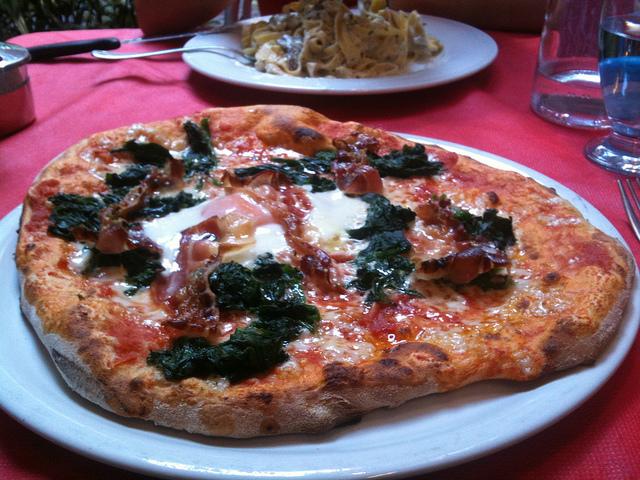Is this pizza house-made?
Be succinct. Yes. How much cheese is on the pizza?
Keep it brief. Little. What is the table made of?
Concise answer only. Wood. What toppings are on this pizza?
Give a very brief answer. Bacon and spinach. What type of vegetable is next to the pizza?
Be succinct. Spinach. Is the table cloth cotton or man made fibers?
Answer briefly. Cotton. Is there a fork on the table?
Quick response, please. Yes. What beverage is being served?
Short answer required. Water. 